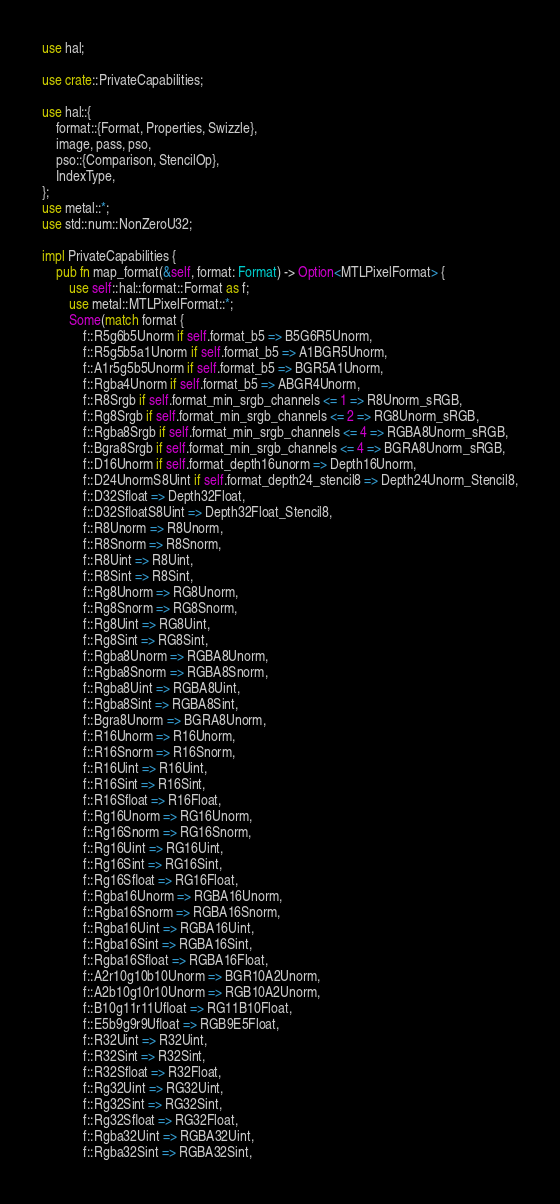Convert code to text. <code><loc_0><loc_0><loc_500><loc_500><_Rust_>use hal;

use crate::PrivateCapabilities;

use hal::{
    format::{Format, Properties, Swizzle},
    image, pass, pso,
    pso::{Comparison, StencilOp},
    IndexType,
};
use metal::*;
use std::num::NonZeroU32;

impl PrivateCapabilities {
    pub fn map_format(&self, format: Format) -> Option<MTLPixelFormat> {
        use self::hal::format::Format as f;
        use metal::MTLPixelFormat::*;
        Some(match format {
            f::R5g6b5Unorm if self.format_b5 => B5G6R5Unorm,
            f::R5g5b5a1Unorm if self.format_b5 => A1BGR5Unorm,
            f::A1r5g5b5Unorm if self.format_b5 => BGR5A1Unorm,
            f::Rgba4Unorm if self.format_b5 => ABGR4Unorm,
            f::R8Srgb if self.format_min_srgb_channels <= 1 => R8Unorm_sRGB,
            f::Rg8Srgb if self.format_min_srgb_channels <= 2 => RG8Unorm_sRGB,
            f::Rgba8Srgb if self.format_min_srgb_channels <= 4 => RGBA8Unorm_sRGB,
            f::Bgra8Srgb if self.format_min_srgb_channels <= 4 => BGRA8Unorm_sRGB,
            f::D16Unorm if self.format_depth16unorm => Depth16Unorm,
            f::D24UnormS8Uint if self.format_depth24_stencil8 => Depth24Unorm_Stencil8,
            f::D32Sfloat => Depth32Float,
            f::D32SfloatS8Uint => Depth32Float_Stencil8,
            f::R8Unorm => R8Unorm,
            f::R8Snorm => R8Snorm,
            f::R8Uint => R8Uint,
            f::R8Sint => R8Sint,
            f::Rg8Unorm => RG8Unorm,
            f::Rg8Snorm => RG8Snorm,
            f::Rg8Uint => RG8Uint,
            f::Rg8Sint => RG8Sint,
            f::Rgba8Unorm => RGBA8Unorm,
            f::Rgba8Snorm => RGBA8Snorm,
            f::Rgba8Uint => RGBA8Uint,
            f::Rgba8Sint => RGBA8Sint,
            f::Bgra8Unorm => BGRA8Unorm,
            f::R16Unorm => R16Unorm,
            f::R16Snorm => R16Snorm,
            f::R16Uint => R16Uint,
            f::R16Sint => R16Sint,
            f::R16Sfloat => R16Float,
            f::Rg16Unorm => RG16Unorm,
            f::Rg16Snorm => RG16Snorm,
            f::Rg16Uint => RG16Uint,
            f::Rg16Sint => RG16Sint,
            f::Rg16Sfloat => RG16Float,
            f::Rgba16Unorm => RGBA16Unorm,
            f::Rgba16Snorm => RGBA16Snorm,
            f::Rgba16Uint => RGBA16Uint,
            f::Rgba16Sint => RGBA16Sint,
            f::Rgba16Sfloat => RGBA16Float,
            f::A2r10g10b10Unorm => BGR10A2Unorm,
            f::A2b10g10r10Unorm => RGB10A2Unorm,
            f::B10g11r11Ufloat => RG11B10Float,
            f::E5b9g9r9Ufloat => RGB9E5Float,
            f::R32Uint => R32Uint,
            f::R32Sint => R32Sint,
            f::R32Sfloat => R32Float,
            f::Rg32Uint => RG32Uint,
            f::Rg32Sint => RG32Sint,
            f::Rg32Sfloat => RG32Float,
            f::Rgba32Uint => RGBA32Uint,
            f::Rgba32Sint => RGBA32Sint,</code> 